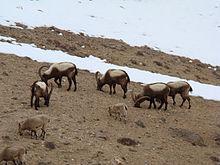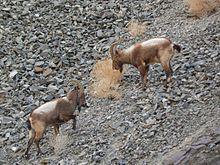The first image is the image on the left, the second image is the image on the right. Assess this claim about the two images: "There is a total of two animals.". Correct or not? Answer yes or no. No. 